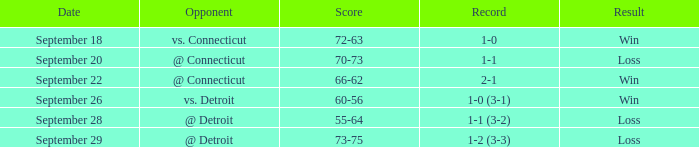Could you parse the entire table as a dict? {'header': ['Date', 'Opponent', 'Score', 'Record', 'Result'], 'rows': [['September 18', 'vs. Connecticut', '72-63', '1-0', 'Win'], ['September 20', '@ Connecticut', '70-73', '1-1', 'Loss'], ['September 22', '@ Connecticut', '66-62', '2-1', 'Win'], ['September 26', 'vs. Detroit', '60-56', '1-0 (3-1)', 'Win'], ['September 28', '@ Detroit', '55-64', '1-1 (3-2)', 'Loss'], ['September 29', '@ Detroit', '73-75', '1-2 (3-3)', 'Loss']]} WHAT IS THE OPPONENT WITH A SCORE OF 72-63? Vs. connecticut. 